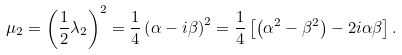<formula> <loc_0><loc_0><loc_500><loc_500>\mu _ { 2 } = \left ( \frac { 1 } { 2 } \lambda _ { 2 } \right ) ^ { 2 } = \frac { 1 } { 4 } \left ( \alpha - i \beta \right ) ^ { 2 } = \frac { 1 } { 4 } \left [ \left ( \alpha ^ { 2 } - \beta ^ { 2 } \right ) - 2 i \alpha \beta \right ] .</formula> 